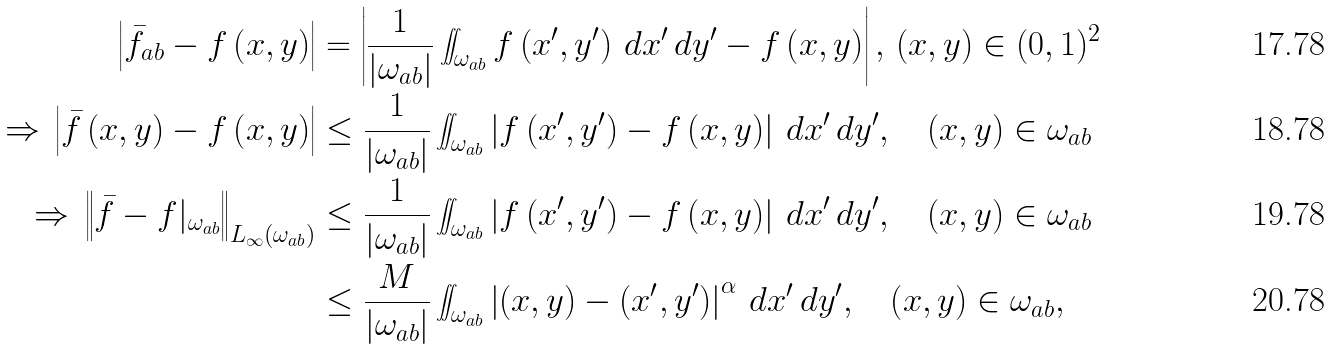Convert formula to latex. <formula><loc_0><loc_0><loc_500><loc_500>\left | { \bar { f } } _ { a b } - f \left ( x , y \right ) \right | & = \left | \frac { 1 } { | \omega _ { a b } | } \iint _ { \omega _ { a b } } f \left ( x ^ { \prime } , y ^ { \prime } \right ) \, d x ^ { \prime } \, d y ^ { \prime } - f \left ( x , y \right ) \right | , \, \left ( x , y \right ) \in ( 0 , 1 ) ^ { 2 } \\ \Rightarrow \, \left | { \bar { f } } \left ( x , y \right ) - f \left ( x , y \right ) \right | & \leq \frac { 1 } { | \omega _ { a b } | } \iint _ { \omega _ { a b } } \left | f \left ( x ^ { \prime } , y ^ { \prime } \right ) - f \left ( x , y \right ) \right | \, d x ^ { \prime } \, d y ^ { \prime } , \quad \left ( x , y \right ) \in \omega _ { a b } \\ \Rightarrow \, \left \| { \bar { f } } - f | _ { \omega _ { a b } } \right \| _ { L _ { \infty } \left ( \omega _ { a b } \right ) } & \leq \frac { 1 } { | \omega _ { a b } | } \iint _ { \omega _ { a b } } \left | f \left ( x ^ { \prime } , y ^ { \prime } \right ) - f \left ( x , y \right ) \right | \, d x ^ { \prime } \, d y ^ { \prime } , \quad \left ( x , y \right ) \in \omega _ { a b } \\ & \leq \frac { M } { | \omega _ { a b } | } \iint _ { \omega _ { a b } } \left | ( x , y ) - ( x ^ { \prime } , y ^ { \prime } ) \right | ^ { \alpha } \, d x ^ { \prime } \, d y ^ { \prime } , \quad \left ( x , y \right ) \in \omega _ { a b } ,</formula> 